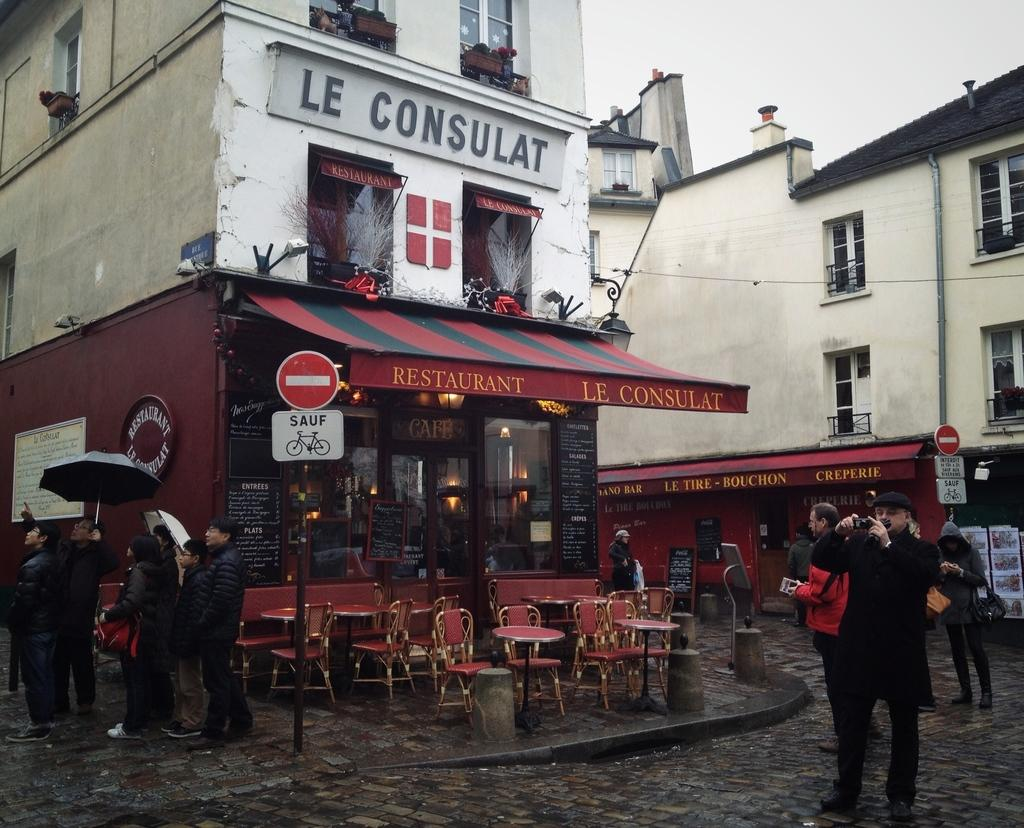What type of structures can be seen in the image? There are buildings in the image. What architectural features are present in the buildings? There are windows in the image. What type of furniture is visible in the image? There are chairs and tables in the image. What object is used for protection from the sun or rain in the image? There is an umbrella in the image. What type of signage is present in the image? There are signboards in the image. What vertical structure is present in the image? There is a pole in the image. Are there any living beings in the image? Yes, there are people in the image. How many trees are present in the image? There are no trees visible in the image. What type of wheel is used by the people in the image? There is no wheel present in the image, and the people are not using any wheels. 